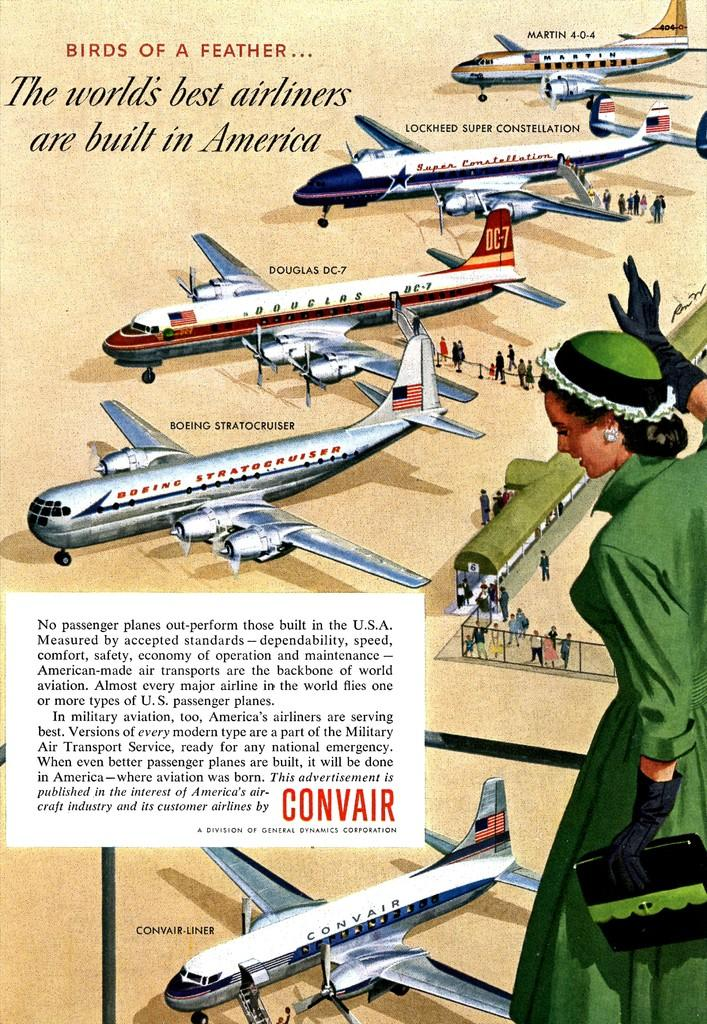<image>
Create a compact narrative representing the image presented. A women in a green dress looks over 5 airplanes, one of them being a Martin 4-0-4 